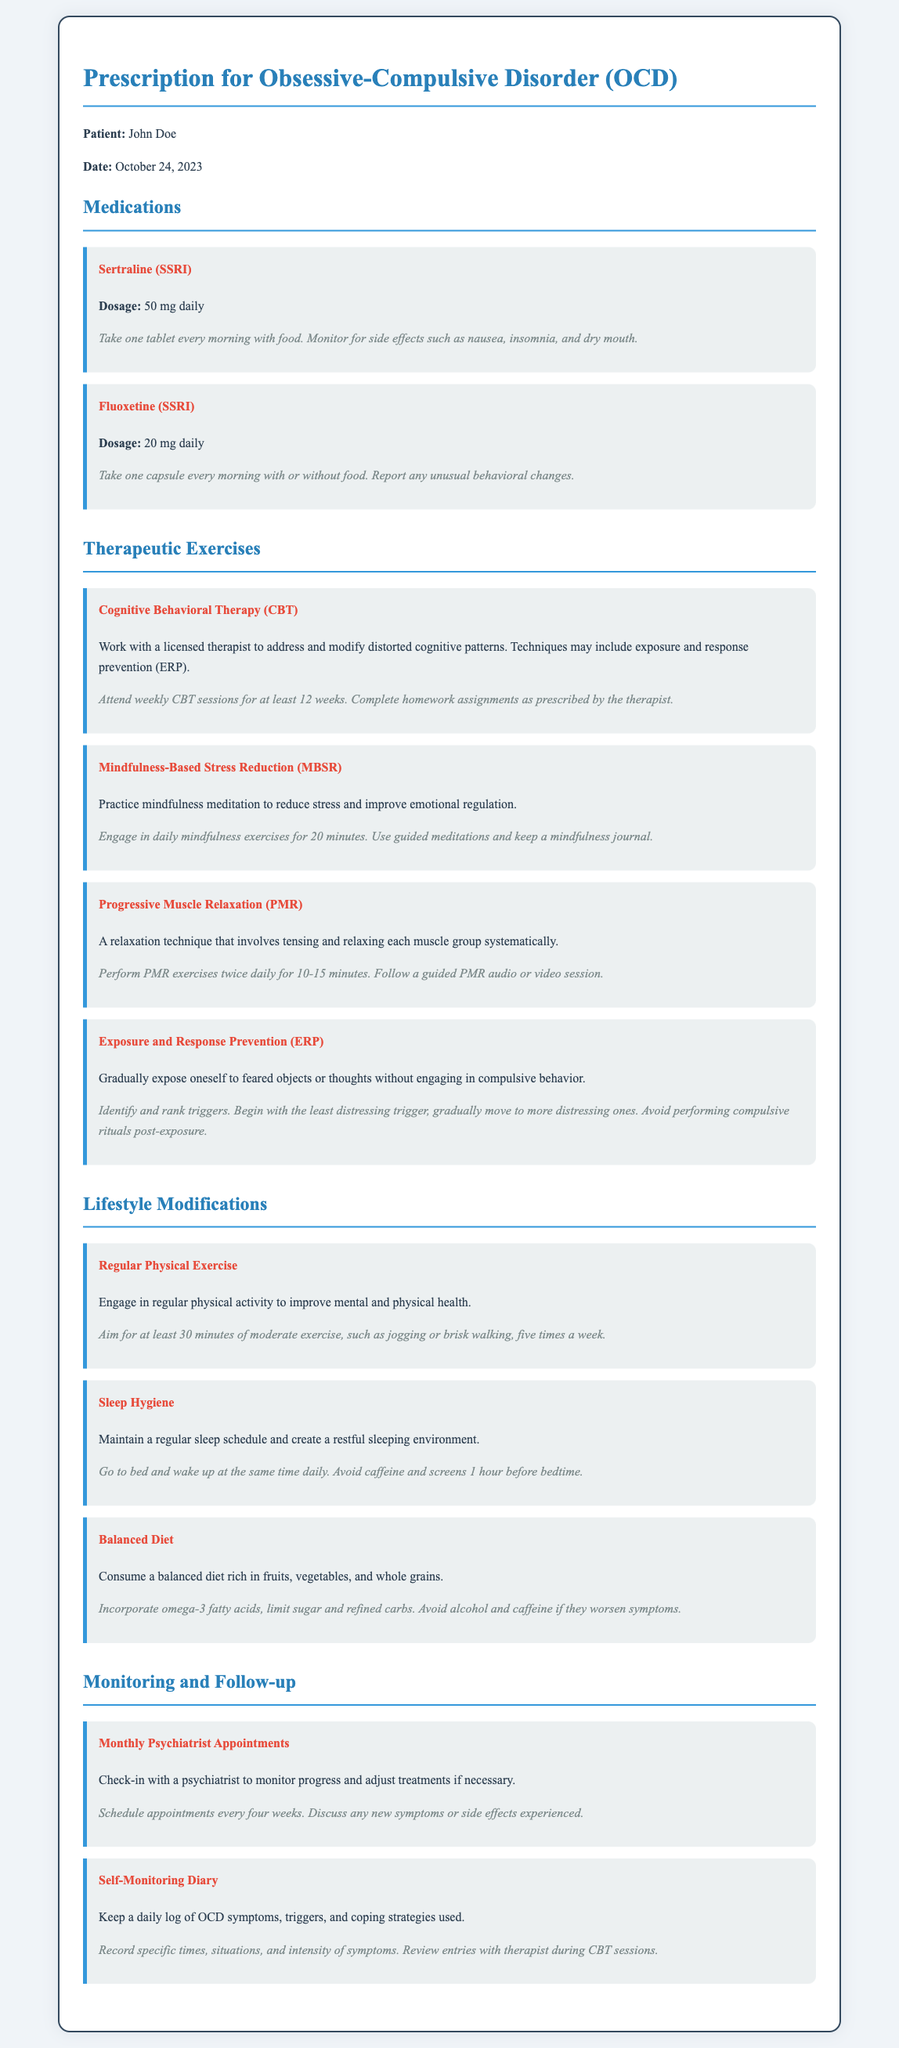What is the patient's name? The patient’s name is listed at the beginning of the document, which is John Doe.
Answer: John Doe What medications are prescribed? The medications listed include Sertraline and Fluoxetine, which are SSRIs.
Answer: Sertraline and Fluoxetine What is the dosage of Sertraline? The dosage for Sertraline is specified in the medication section of the document, which is 50 mg daily.
Answer: 50 mg daily How often should cognitive behavioral therapy sessions be attended? The document specifies that CBT sessions should be attended weekly for at least 12 weeks.
Answer: Weekly for at least 12 weeks What lifestyle modification involves physical activity? The lifestyle modification that involves physical activity is "Regular Physical Exercise."
Answer: Regular Physical Exercise How long should mindfulness exercises be practiced daily? The instructions for mindfulness exercises indicate a duration of 20 minutes every day.
Answer: 20 minutes What is required for self-monitoring? The self-monitoring requirement involves keeping a daily log of OCD symptoms, triggers, and coping strategies used.
Answer: Daily log of OCD symptoms When should follow-up appointments with the psychiatrist occur? Follow-up appointments should be scheduled every four weeks as stated in the monitoring section.
Answer: Every four weeks What should be avoided before bedtime? The document mentions avoiding caffeine and screens 1 hour before bedtime as part of sleep hygiene.
Answer: Caffeine and screens 